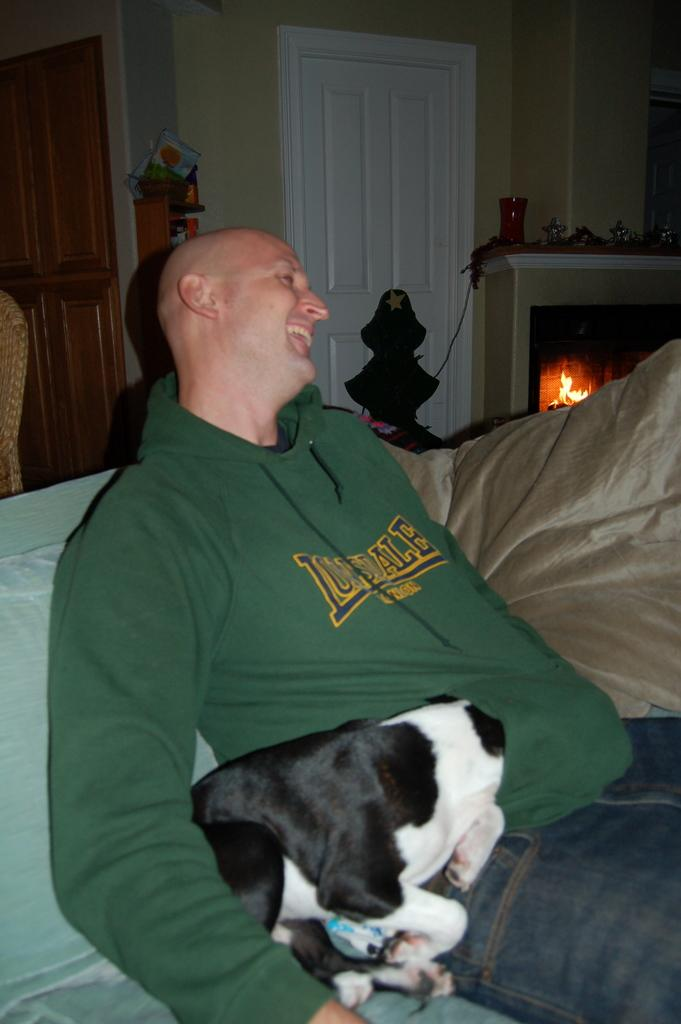Who or what is present on the sofa in the image? There is a person and a dog on the sofa in the image. What can be seen on the right side of the image? There is a fireplace on the right side of the image. Where is the door located in the image? The door is at the top and on the left side of the image. How does the person help the dog with the dirt in the image? There is no dirt present in the image, and no indication that the person is helping the dog with anything. 